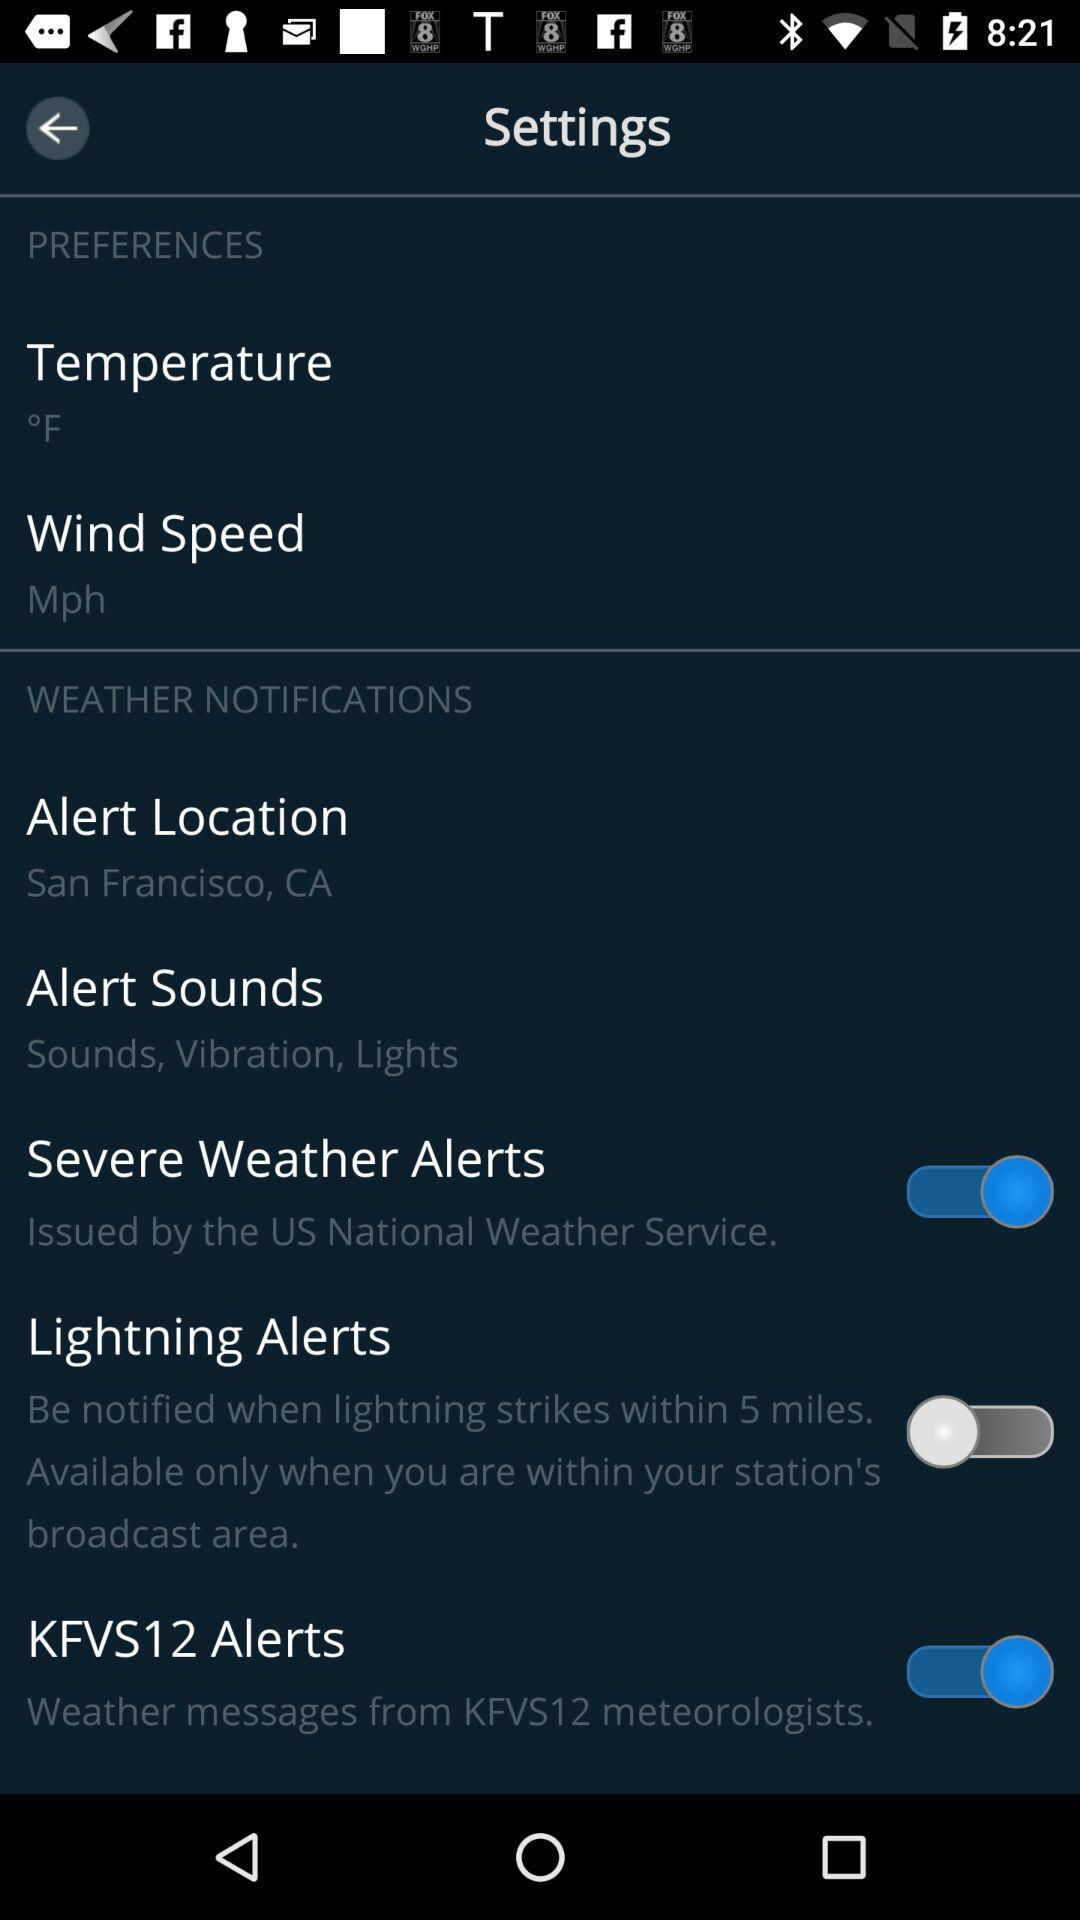Who issues severe weather alerts? The severe weather alert is issued by the US National Weather Service. 